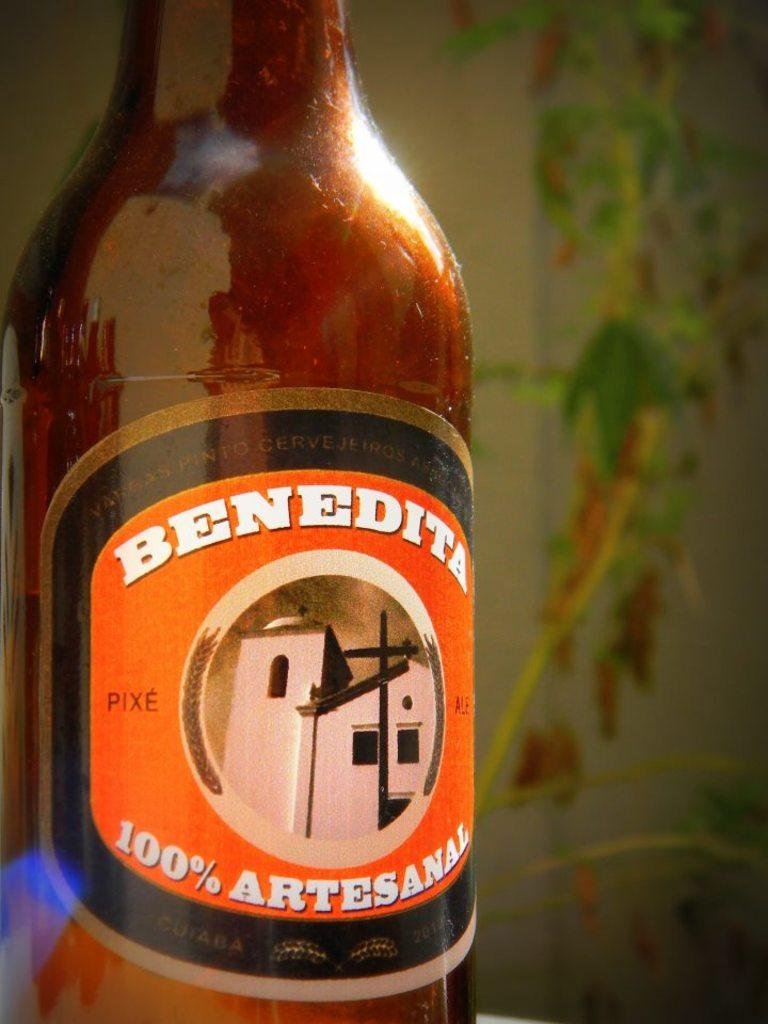<image>
Offer a succinct explanation of the picture presented. a close up of a bottle of Benedita 100% Artesanal drink 